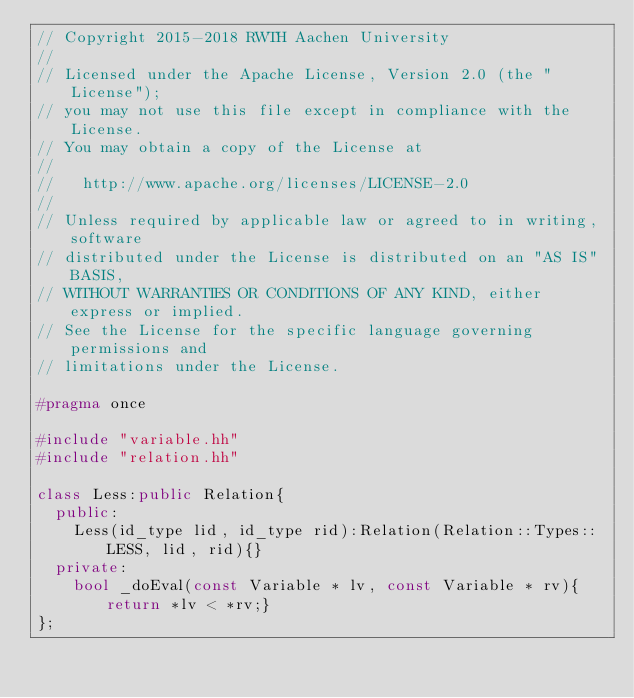<code> <loc_0><loc_0><loc_500><loc_500><_C++_>// Copyright 2015-2018 RWTH Aachen University
//
// Licensed under the Apache License, Version 2.0 (the "License");
// you may not use this file except in compliance with the License.
// You may obtain a copy of the License at
//
//   http://www.apache.org/licenses/LICENSE-2.0
//
// Unless required by applicable law or agreed to in writing, software
// distributed under the License is distributed on an "AS IS" BASIS,
// WITHOUT WARRANTIES OR CONDITIONS OF ANY KIND, either express or implied.
// See the License for the specific language governing permissions and
// limitations under the License.

#pragma once

#include "variable.hh"
#include "relation.hh"

class Less:public Relation{
	public:
		Less(id_type lid, id_type rid):Relation(Relation::Types::LESS, lid, rid){}
	private:
		bool _doEval(const Variable * lv, const Variable * rv){return *lv < *rv;}
};

</code> 